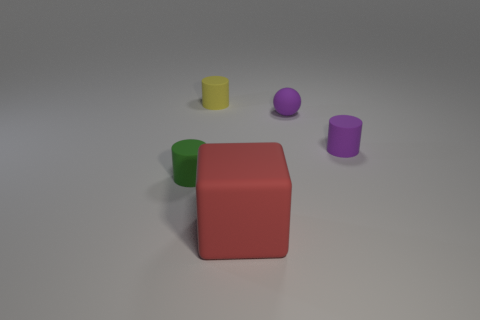Add 3 red rubber things. How many objects exist? 8 Subtract all cylinders. How many objects are left? 2 Subtract all tiny green cylinders. Subtract all small rubber balls. How many objects are left? 3 Add 4 large red things. How many large red things are left? 5 Add 5 small matte cylinders. How many small matte cylinders exist? 8 Subtract 1 purple cylinders. How many objects are left? 4 